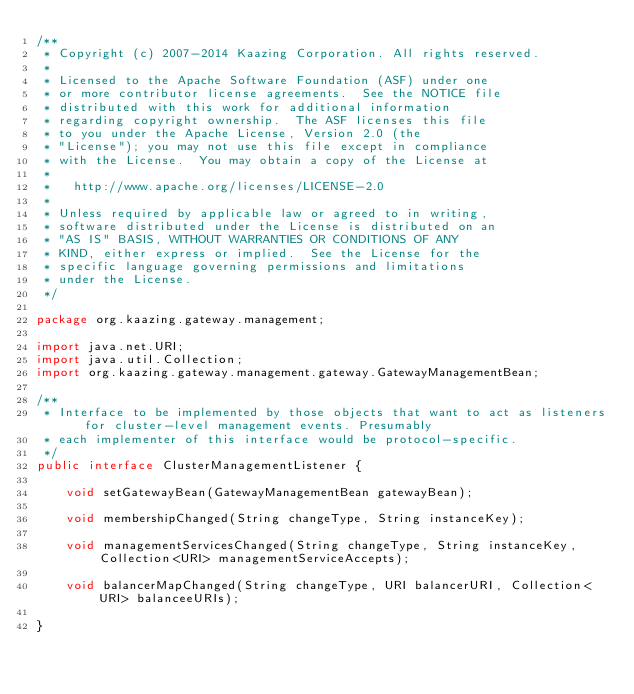<code> <loc_0><loc_0><loc_500><loc_500><_Java_>/**
 * Copyright (c) 2007-2014 Kaazing Corporation. All rights reserved.
 *
 * Licensed to the Apache Software Foundation (ASF) under one
 * or more contributor license agreements.  See the NOTICE file
 * distributed with this work for additional information
 * regarding copyright ownership.  The ASF licenses this file
 * to you under the Apache License, Version 2.0 (the
 * "License"); you may not use this file except in compliance
 * with the License.  You may obtain a copy of the License at
 *
 *   http://www.apache.org/licenses/LICENSE-2.0
 *
 * Unless required by applicable law or agreed to in writing,
 * software distributed under the License is distributed on an
 * "AS IS" BASIS, WITHOUT WARRANTIES OR CONDITIONS OF ANY
 * KIND, either express or implied.  See the License for the
 * specific language governing permissions and limitations
 * under the License.
 */

package org.kaazing.gateway.management;

import java.net.URI;
import java.util.Collection;
import org.kaazing.gateway.management.gateway.GatewayManagementBean;

/**
 * Interface to be implemented by those objects that want to act as listeners for cluster-level management events. Presumably
 * each implementer of this interface would be protocol-specific.
 */
public interface ClusterManagementListener {

    void setGatewayBean(GatewayManagementBean gatewayBean);

    void membershipChanged(String changeType, String instanceKey);

    void managementServicesChanged(String changeType, String instanceKey, Collection<URI> managementServiceAccepts);

    void balancerMapChanged(String changeType, URI balancerURI, Collection<URI> balanceeURIs);

}
</code> 